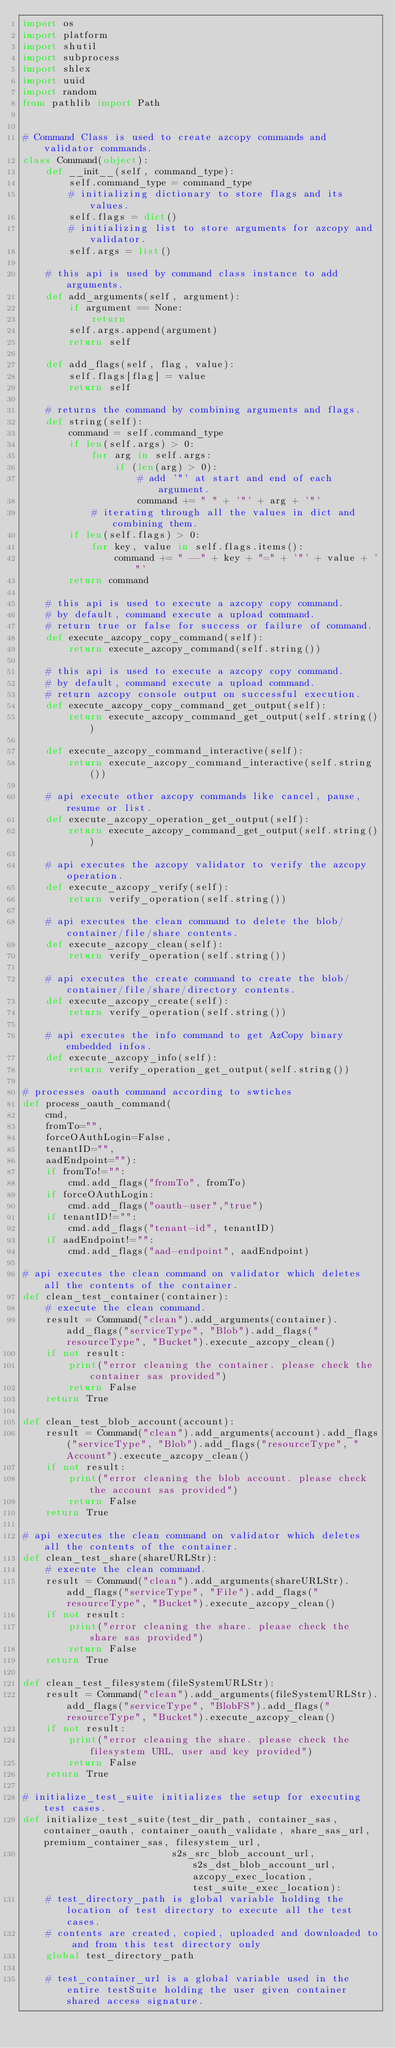Convert code to text. <code><loc_0><loc_0><loc_500><loc_500><_Python_>import os
import platform
import shutil
import subprocess
import shlex
import uuid
import random
from pathlib import Path


# Command Class is used to create azcopy commands and validator commands.
class Command(object):
    def __init__(self, command_type):
        self.command_type = command_type
        # initializing dictionary to store flags and its values.
        self.flags = dict()
        # initializing list to store arguments for azcopy and validator.
        self.args = list()

    # this api is used by command class instance to add arguments.
    def add_arguments(self, argument):
        if argument == None:
            return
        self.args.append(argument)
        return self

    def add_flags(self, flag, value):
        self.flags[flag] = value
        return self

    # returns the command by combining arguments and flags.
    def string(self):
        command = self.command_type
        if len(self.args) > 0:
            for arg in self.args:
                if (len(arg) > 0):
                    # add '"' at start and end of each argument.
                    command += " " + '"' + arg + '"'
            # iterating through all the values in dict and combining them.
        if len(self.flags) > 0:
            for key, value in self.flags.items():
                command += " --" + key + "=" + '"' + value + '"'
        return command

    # this api is used to execute a azcopy copy command.
    # by default, command execute a upload command.
    # return true or false for success or failure of command.
    def execute_azcopy_copy_command(self):
        return execute_azcopy_command(self.string())

    # this api is used to execute a azcopy copy command.
    # by default, command execute a upload command.
    # return azcopy console output on successful execution.
    def execute_azcopy_copy_command_get_output(self):
        return execute_azcopy_command_get_output(self.string())

    def execute_azcopy_command_interactive(self):
        return execute_azcopy_command_interactive(self.string())

    # api execute other azcopy commands like cancel, pause, resume or list.
    def execute_azcopy_operation_get_output(self):
        return execute_azcopy_command_get_output(self.string())

    # api executes the azcopy validator to verify the azcopy operation.
    def execute_azcopy_verify(self):
        return verify_operation(self.string())

    # api executes the clean command to delete the blob/container/file/share contents.
    def execute_azcopy_clean(self):
        return verify_operation(self.string())

    # api executes the create command to create the blob/container/file/share/directory contents.
    def execute_azcopy_create(self):
        return verify_operation(self.string())

    # api executes the info command to get AzCopy binary embedded infos.
    def execute_azcopy_info(self):
        return verify_operation_get_output(self.string())

# processes oauth command according to swtiches
def process_oauth_command(
    cmd,
    fromTo="",
    forceOAuthLogin=False,
    tenantID="",
    aadEndpoint=""):
    if fromTo!="":
        cmd.add_flags("fromTo", fromTo)
    if forceOAuthLogin:
        cmd.add_flags("oauth-user","true")
    if tenantID!="":
        cmd.add_flags("tenant-id", tenantID)
    if aadEndpoint!="":
        cmd.add_flags("aad-endpoint", aadEndpoint)

# api executes the clean command on validator which deletes all the contents of the container.
def clean_test_container(container):
    # execute the clean command.
    result = Command("clean").add_arguments(container).add_flags("serviceType", "Blob").add_flags("resourceType", "Bucket").execute_azcopy_clean()
    if not result:
        print("error cleaning the container. please check the container sas provided")
        return False
    return True

def clean_test_blob_account(account):
    result = Command("clean").add_arguments(account).add_flags("serviceType", "Blob").add_flags("resourceType", "Account").execute_azcopy_clean()
    if not result:
        print("error cleaning the blob account. please check the account sas provided")
        return False
    return True

# api executes the clean command on validator which deletes all the contents of the container.
def clean_test_share(shareURLStr):
    # execute the clean command.
    result = Command("clean").add_arguments(shareURLStr).add_flags("serviceType", "File").add_flags("resourceType", "Bucket").execute_azcopy_clean()
    if not result:
        print("error cleaning the share. please check the share sas provided")
        return False
    return True

def clean_test_filesystem(fileSystemURLStr):
    result = Command("clean").add_arguments(fileSystemURLStr).add_flags("serviceType", "BlobFS").add_flags("resourceType", "Bucket").execute_azcopy_clean()
    if not result:
        print("error cleaning the share. please check the filesystem URL, user and key provided")
        return False
    return True

# initialize_test_suite initializes the setup for executing test cases.
def initialize_test_suite(test_dir_path, container_sas, container_oauth, container_oauth_validate, share_sas_url, premium_container_sas, filesystem_url, 
                          s2s_src_blob_account_url, s2s_dst_blob_account_url, azcopy_exec_location, test_suite_exec_location):
    # test_directory_path is global variable holding the location of test directory to execute all the test cases.
    # contents are created, copied, uploaded and downloaded to and from this test directory only
    global test_directory_path

    # test_container_url is a global variable used in the entire testSuite holding the user given container shared access signature.</code> 